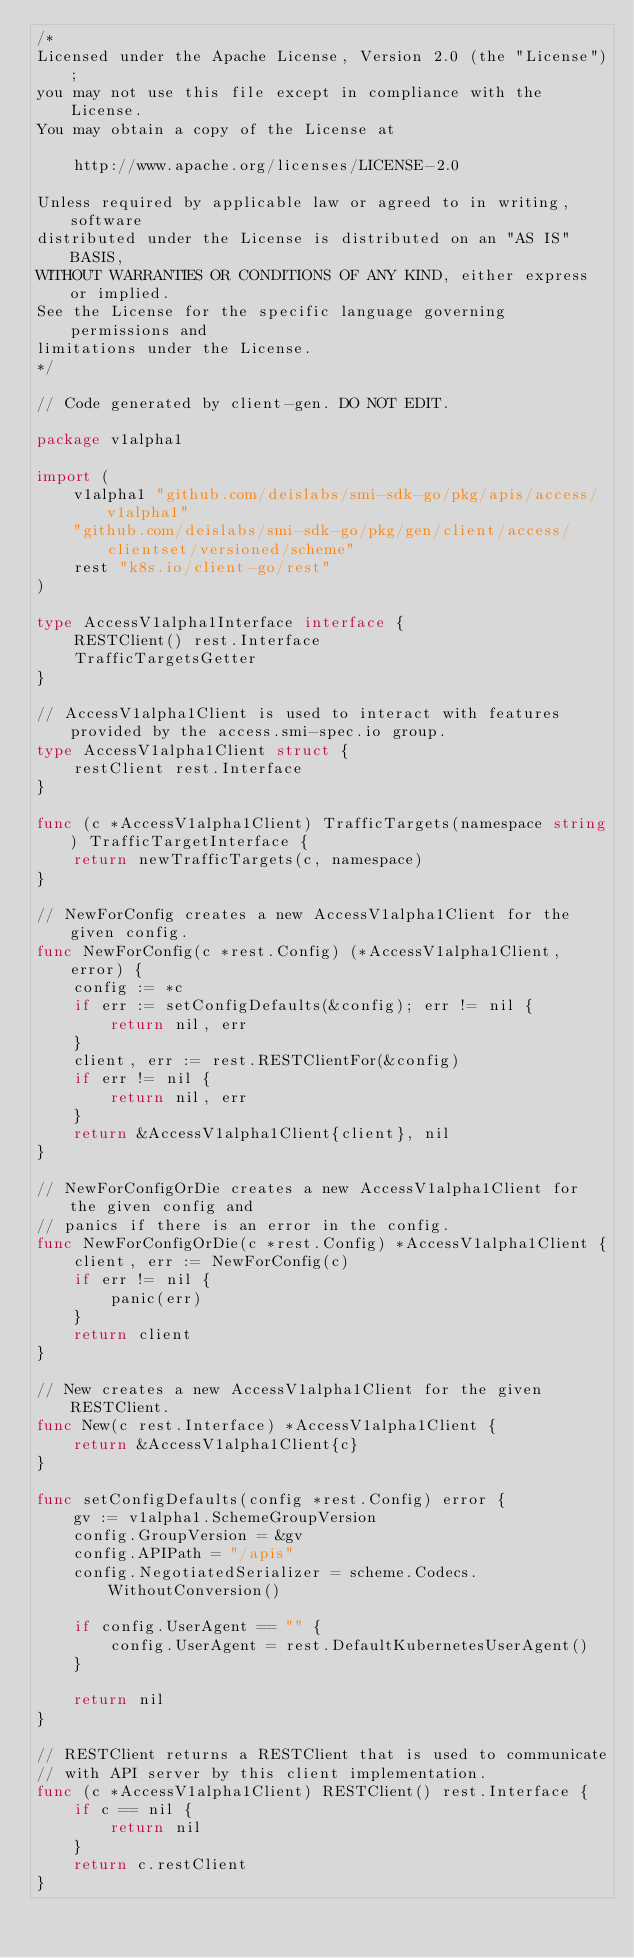Convert code to text. <code><loc_0><loc_0><loc_500><loc_500><_Go_>/*
Licensed under the Apache License, Version 2.0 (the "License");
you may not use this file except in compliance with the License.
You may obtain a copy of the License at

    http://www.apache.org/licenses/LICENSE-2.0

Unless required by applicable law or agreed to in writing, software
distributed under the License is distributed on an "AS IS" BASIS,
WITHOUT WARRANTIES OR CONDITIONS OF ANY KIND, either express or implied.
See the License for the specific language governing permissions and
limitations under the License.
*/

// Code generated by client-gen. DO NOT EDIT.

package v1alpha1

import (
	v1alpha1 "github.com/deislabs/smi-sdk-go/pkg/apis/access/v1alpha1"
	"github.com/deislabs/smi-sdk-go/pkg/gen/client/access/clientset/versioned/scheme"
	rest "k8s.io/client-go/rest"
)

type AccessV1alpha1Interface interface {
	RESTClient() rest.Interface
	TrafficTargetsGetter
}

// AccessV1alpha1Client is used to interact with features provided by the access.smi-spec.io group.
type AccessV1alpha1Client struct {
	restClient rest.Interface
}

func (c *AccessV1alpha1Client) TrafficTargets(namespace string) TrafficTargetInterface {
	return newTrafficTargets(c, namespace)
}

// NewForConfig creates a new AccessV1alpha1Client for the given config.
func NewForConfig(c *rest.Config) (*AccessV1alpha1Client, error) {
	config := *c
	if err := setConfigDefaults(&config); err != nil {
		return nil, err
	}
	client, err := rest.RESTClientFor(&config)
	if err != nil {
		return nil, err
	}
	return &AccessV1alpha1Client{client}, nil
}

// NewForConfigOrDie creates a new AccessV1alpha1Client for the given config and
// panics if there is an error in the config.
func NewForConfigOrDie(c *rest.Config) *AccessV1alpha1Client {
	client, err := NewForConfig(c)
	if err != nil {
		panic(err)
	}
	return client
}

// New creates a new AccessV1alpha1Client for the given RESTClient.
func New(c rest.Interface) *AccessV1alpha1Client {
	return &AccessV1alpha1Client{c}
}

func setConfigDefaults(config *rest.Config) error {
	gv := v1alpha1.SchemeGroupVersion
	config.GroupVersion = &gv
	config.APIPath = "/apis"
	config.NegotiatedSerializer = scheme.Codecs.WithoutConversion()

	if config.UserAgent == "" {
		config.UserAgent = rest.DefaultKubernetesUserAgent()
	}

	return nil
}

// RESTClient returns a RESTClient that is used to communicate
// with API server by this client implementation.
func (c *AccessV1alpha1Client) RESTClient() rest.Interface {
	if c == nil {
		return nil
	}
	return c.restClient
}
</code> 